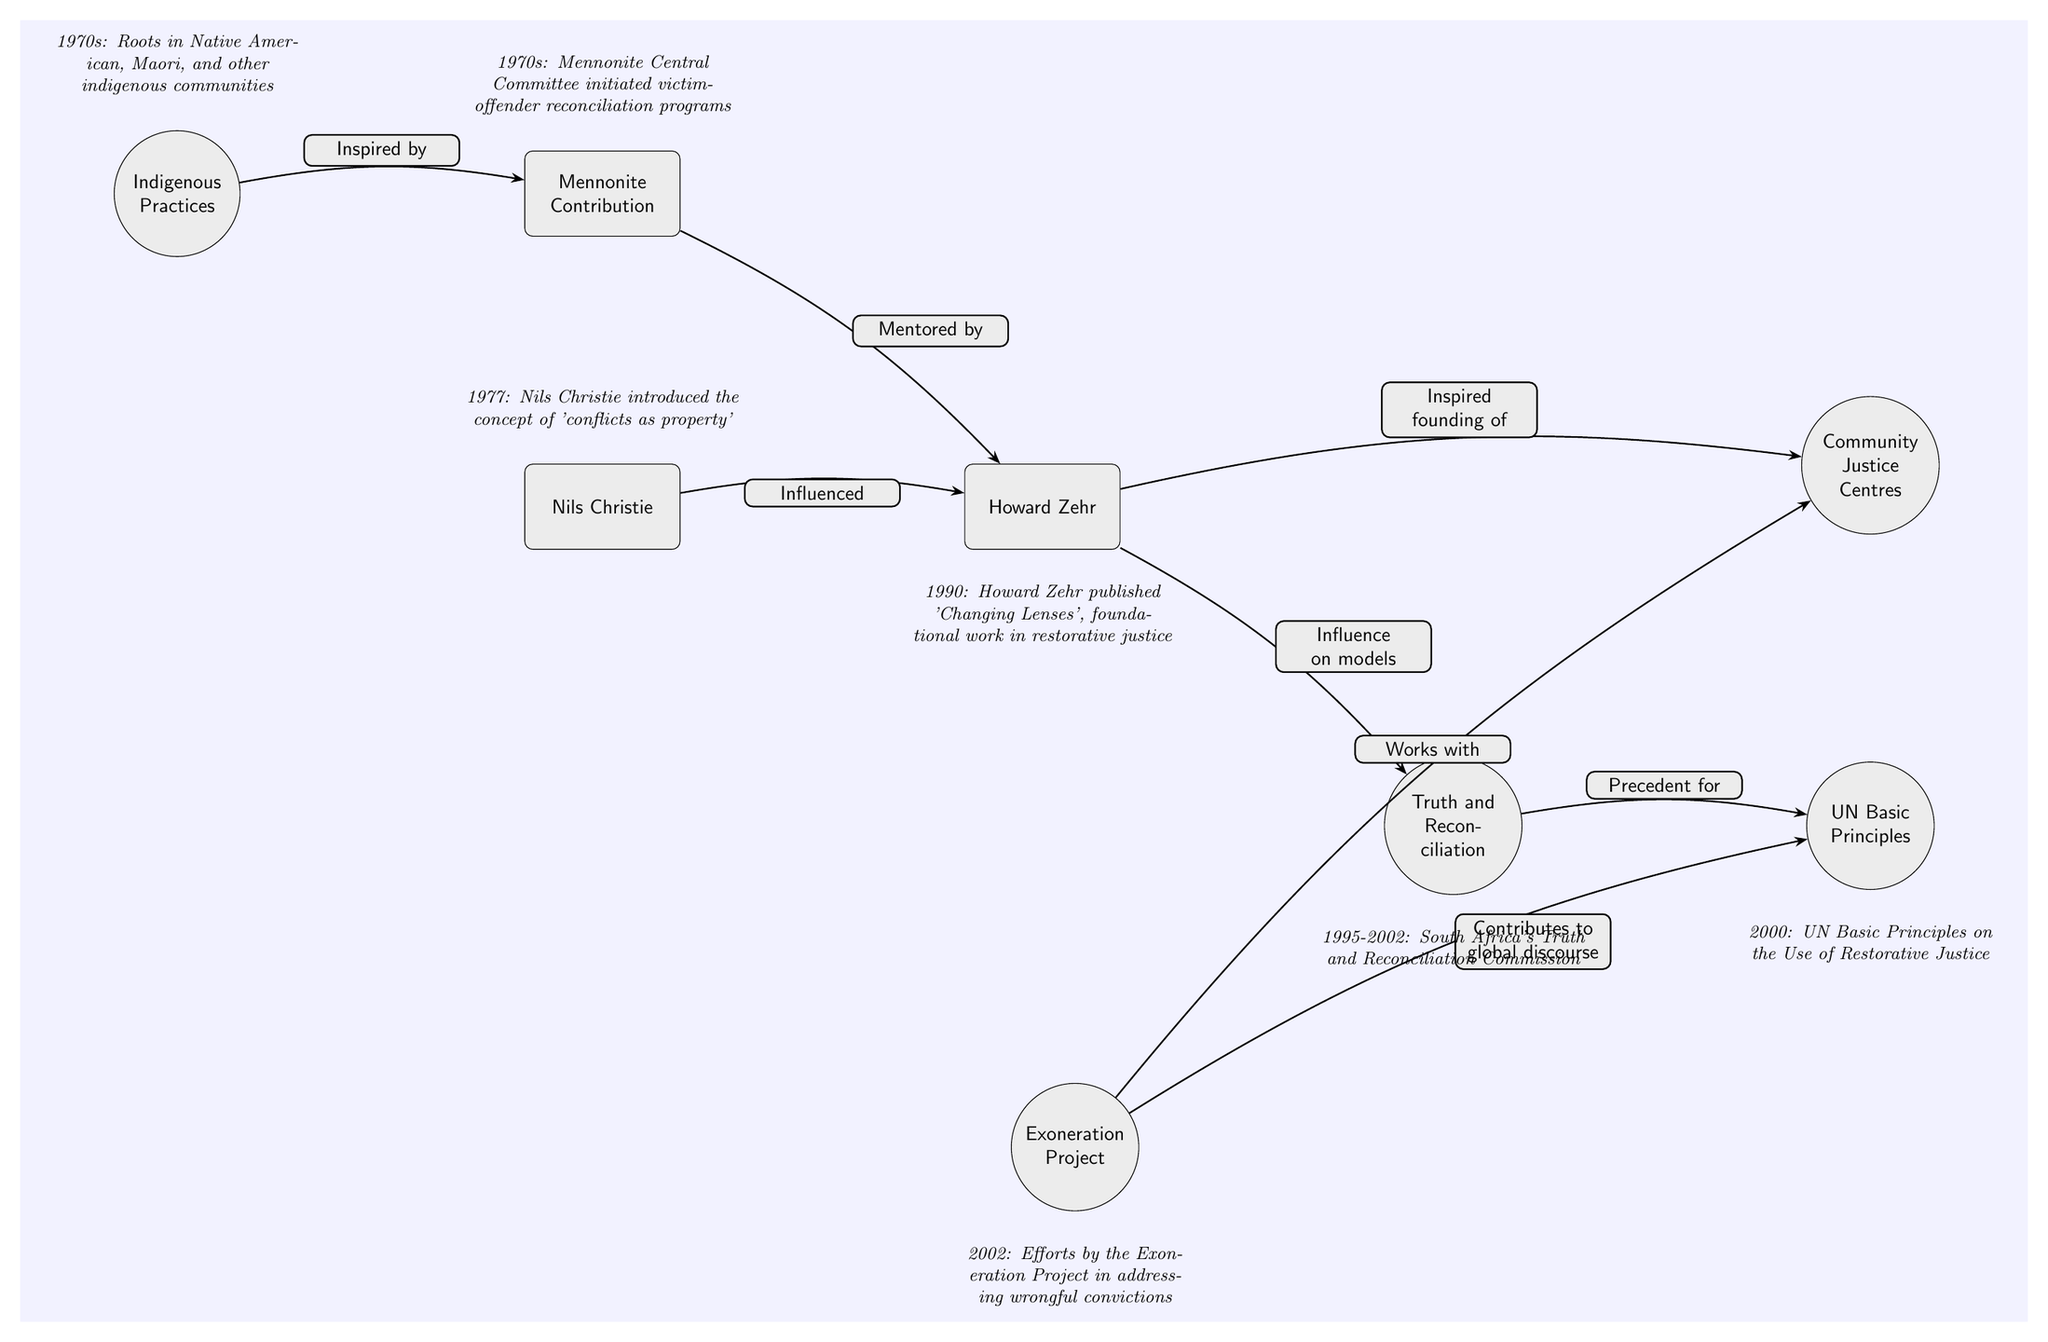What inspired the Mennonite Contribution? The diagram indicates that the Mennonite Contribution was inspired by Indigenous Practices. This relationship is depicted with an arrow from the node "Indigenous Practices" to the node "Mennonite Contribution" stating "Inspired by."
Answer: Indigenous Practices Who mentored Howard Zehr? According to the diagram, Howard Zehr was mentored by the Mennonite Contribution, as indicated by the "Mentored by" label on the arrow connecting the two nodes.
Answer: Mennonite Contribution What concept did Nils Christie introduce in 1977? The diagram states that in 1977, Nils Christie introduced the concept of 'conflicts as property.' This information is directed by the timeline node placed above Nils Christie's node.
Answer: conflicts as property What significant event did the South Africa's Truth and Reconciliation Commission occur between? The timeline above the "Truth and Reconciliation" event node shows that this significant event occurred from 1995 to 2002. It is crucial to look at the label connected to this node to find this date range.
Answer: 1995-2002 How did Howard Zehr influence models of justice? The influence of Howard Zehr on models of justice is depicted with an arrow labeled "Influence on models" connecting Howard Zehr's node to the "Truth and Reconciliation" event node. Displays a direct connection between Zehr and the evolving models of justice.
Answer: Influence on models What year was the UN Basic Principles on the Use of Restorative Justice established? A glance at the timeline node above the "UN Basic Principles" event shows that this document was established in the year 2000. This node provides clear and concise data for the year of establishment.
Answer: 2000 Which two nodes are associated with the Exoneration Project? The Exoneration Project interacts with two nodes: the "Community Justice Centres" and the "UN Basic Principles." The diagram shows arrows labeled with "Works with" and "Contributes to global discourse," indicating these relationships.
Answer: Community Justice Centres, UN Basic Principles Why is Howard Zehr considered a foundational figure in restorative justice? The diagram indicates that Howard Zehr published 'Changing Lenses' in 1990, labeled as a foundational work in restorative justice. This significance highlights his major contributions through the publication of this pivotal text.
Answer: foundational work in restorative justice What do the arrows connecting the nodes represent? The arrows connecting the nodes represent the relationships and influences among the different figures and events in the history of restorative justice. Each arrow is labeled with a specific relationship term that clarifies these connections.
Answer: Relationships and influences 